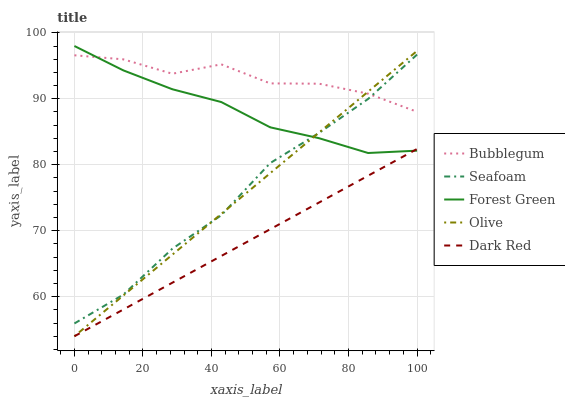Does Dark Red have the minimum area under the curve?
Answer yes or no. Yes. Does Bubblegum have the maximum area under the curve?
Answer yes or no. Yes. Does Forest Green have the minimum area under the curve?
Answer yes or no. No. Does Forest Green have the maximum area under the curve?
Answer yes or no. No. Is Dark Red the smoothest?
Answer yes or no. Yes. Is Bubblegum the roughest?
Answer yes or no. Yes. Is Forest Green the smoothest?
Answer yes or no. No. Is Forest Green the roughest?
Answer yes or no. No. Does Olive have the lowest value?
Answer yes or no. Yes. Does Forest Green have the lowest value?
Answer yes or no. No. Does Forest Green have the highest value?
Answer yes or no. Yes. Does Dark Red have the highest value?
Answer yes or no. No. Is Dark Red less than Seafoam?
Answer yes or no. Yes. Is Seafoam greater than Dark Red?
Answer yes or no. Yes. Does Olive intersect Forest Green?
Answer yes or no. Yes. Is Olive less than Forest Green?
Answer yes or no. No. Is Olive greater than Forest Green?
Answer yes or no. No. Does Dark Red intersect Seafoam?
Answer yes or no. No. 